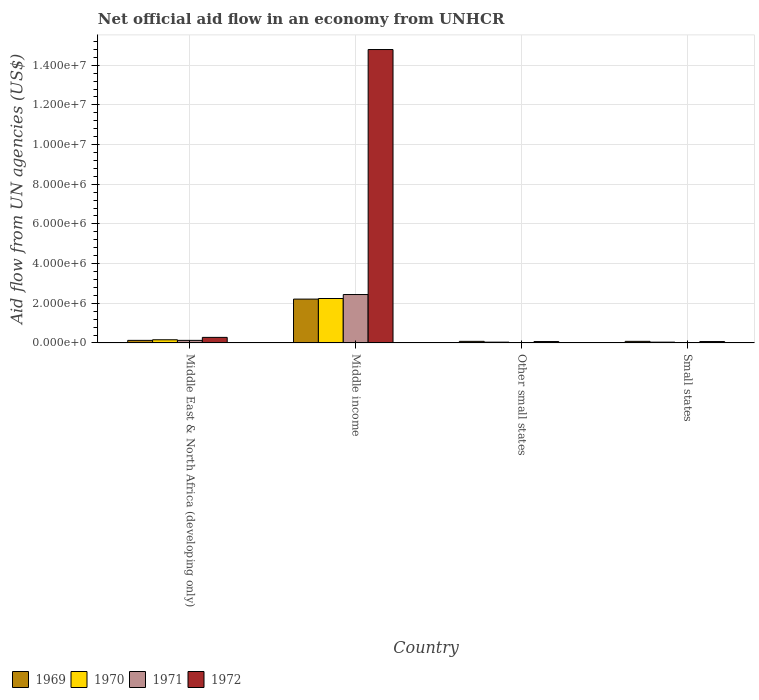How many groups of bars are there?
Provide a short and direct response. 4. Are the number of bars per tick equal to the number of legend labels?
Your answer should be compact. Yes. Are the number of bars on each tick of the X-axis equal?
Your answer should be very brief. Yes. How many bars are there on the 4th tick from the left?
Ensure brevity in your answer.  4. How many bars are there on the 1st tick from the right?
Give a very brief answer. 4. What is the label of the 4th group of bars from the left?
Give a very brief answer. Small states. Across all countries, what is the maximum net official aid flow in 1970?
Provide a succinct answer. 2.24e+06. Across all countries, what is the minimum net official aid flow in 1970?
Provide a succinct answer. 4.00e+04. In which country was the net official aid flow in 1969 minimum?
Your answer should be compact. Other small states. What is the total net official aid flow in 1970 in the graph?
Offer a very short reply. 2.48e+06. What is the difference between the net official aid flow in 1972 in Middle East & North Africa (developing only) and that in Middle income?
Make the answer very short. -1.45e+07. What is the difference between the net official aid flow in 1972 in Middle income and the net official aid flow in 1969 in Other small states?
Your answer should be compact. 1.47e+07. What is the average net official aid flow in 1970 per country?
Provide a succinct answer. 6.20e+05. What is the difference between the net official aid flow of/in 1972 and net official aid flow of/in 1971 in Middle income?
Provide a succinct answer. 1.24e+07. In how many countries, is the net official aid flow in 1969 greater than 14000000 US$?
Offer a terse response. 0. Is the net official aid flow in 1972 in Middle East & North Africa (developing only) less than that in Middle income?
Keep it short and to the point. Yes. What is the difference between the highest and the second highest net official aid flow in 1971?
Your answer should be compact. 2.42e+06. What is the difference between the highest and the lowest net official aid flow in 1971?
Offer a very short reply. 2.42e+06. Is it the case that in every country, the sum of the net official aid flow in 1971 and net official aid flow in 1969 is greater than the sum of net official aid flow in 1972 and net official aid flow in 1970?
Make the answer very short. No. What does the 1st bar from the left in Small states represents?
Provide a short and direct response. 1969. Is it the case that in every country, the sum of the net official aid flow in 1971 and net official aid flow in 1972 is greater than the net official aid flow in 1970?
Your answer should be very brief. Yes. What is the difference between two consecutive major ticks on the Y-axis?
Keep it short and to the point. 2.00e+06. Are the values on the major ticks of Y-axis written in scientific E-notation?
Your answer should be compact. Yes. Where does the legend appear in the graph?
Your answer should be compact. Bottom left. How are the legend labels stacked?
Offer a terse response. Horizontal. What is the title of the graph?
Offer a terse response. Net official aid flow in an economy from UNHCR. What is the label or title of the Y-axis?
Provide a short and direct response. Aid flow from UN agencies (US$). What is the Aid flow from UN agencies (US$) of 1969 in Middle East & North Africa (developing only)?
Provide a succinct answer. 1.30e+05. What is the Aid flow from UN agencies (US$) of 1970 in Middle East & North Africa (developing only)?
Give a very brief answer. 1.60e+05. What is the Aid flow from UN agencies (US$) in 1971 in Middle East & North Africa (developing only)?
Provide a short and direct response. 1.30e+05. What is the Aid flow from UN agencies (US$) in 1972 in Middle East & North Africa (developing only)?
Your response must be concise. 2.80e+05. What is the Aid flow from UN agencies (US$) in 1969 in Middle income?
Offer a terse response. 2.21e+06. What is the Aid flow from UN agencies (US$) in 1970 in Middle income?
Your answer should be very brief. 2.24e+06. What is the Aid flow from UN agencies (US$) of 1971 in Middle income?
Your answer should be compact. 2.44e+06. What is the Aid flow from UN agencies (US$) in 1972 in Middle income?
Make the answer very short. 1.48e+07. What is the Aid flow from UN agencies (US$) of 1970 in Other small states?
Your response must be concise. 4.00e+04. What is the Aid flow from UN agencies (US$) of 1971 in Other small states?
Provide a short and direct response. 2.00e+04. What is the Aid flow from UN agencies (US$) of 1972 in Other small states?
Make the answer very short. 7.00e+04. What is the Aid flow from UN agencies (US$) of 1970 in Small states?
Your response must be concise. 4.00e+04. What is the Aid flow from UN agencies (US$) of 1972 in Small states?
Provide a short and direct response. 7.00e+04. Across all countries, what is the maximum Aid flow from UN agencies (US$) in 1969?
Ensure brevity in your answer.  2.21e+06. Across all countries, what is the maximum Aid flow from UN agencies (US$) in 1970?
Ensure brevity in your answer.  2.24e+06. Across all countries, what is the maximum Aid flow from UN agencies (US$) in 1971?
Give a very brief answer. 2.44e+06. Across all countries, what is the maximum Aid flow from UN agencies (US$) of 1972?
Keep it short and to the point. 1.48e+07. Across all countries, what is the minimum Aid flow from UN agencies (US$) in 1969?
Offer a terse response. 8.00e+04. Across all countries, what is the minimum Aid flow from UN agencies (US$) of 1970?
Provide a short and direct response. 4.00e+04. Across all countries, what is the minimum Aid flow from UN agencies (US$) in 1971?
Keep it short and to the point. 2.00e+04. What is the total Aid flow from UN agencies (US$) of 1969 in the graph?
Offer a very short reply. 2.50e+06. What is the total Aid flow from UN agencies (US$) in 1970 in the graph?
Your response must be concise. 2.48e+06. What is the total Aid flow from UN agencies (US$) in 1971 in the graph?
Your response must be concise. 2.61e+06. What is the total Aid flow from UN agencies (US$) in 1972 in the graph?
Keep it short and to the point. 1.52e+07. What is the difference between the Aid flow from UN agencies (US$) in 1969 in Middle East & North Africa (developing only) and that in Middle income?
Provide a short and direct response. -2.08e+06. What is the difference between the Aid flow from UN agencies (US$) of 1970 in Middle East & North Africa (developing only) and that in Middle income?
Provide a short and direct response. -2.08e+06. What is the difference between the Aid flow from UN agencies (US$) of 1971 in Middle East & North Africa (developing only) and that in Middle income?
Your answer should be compact. -2.31e+06. What is the difference between the Aid flow from UN agencies (US$) in 1972 in Middle East & North Africa (developing only) and that in Middle income?
Provide a succinct answer. -1.45e+07. What is the difference between the Aid flow from UN agencies (US$) in 1969 in Middle East & North Africa (developing only) and that in Other small states?
Your answer should be very brief. 5.00e+04. What is the difference between the Aid flow from UN agencies (US$) of 1970 in Middle East & North Africa (developing only) and that in Other small states?
Your answer should be compact. 1.20e+05. What is the difference between the Aid flow from UN agencies (US$) of 1972 in Middle East & North Africa (developing only) and that in Other small states?
Make the answer very short. 2.10e+05. What is the difference between the Aid flow from UN agencies (US$) of 1969 in Middle East & North Africa (developing only) and that in Small states?
Your answer should be compact. 5.00e+04. What is the difference between the Aid flow from UN agencies (US$) in 1969 in Middle income and that in Other small states?
Give a very brief answer. 2.13e+06. What is the difference between the Aid flow from UN agencies (US$) of 1970 in Middle income and that in Other small states?
Ensure brevity in your answer.  2.20e+06. What is the difference between the Aid flow from UN agencies (US$) of 1971 in Middle income and that in Other small states?
Give a very brief answer. 2.42e+06. What is the difference between the Aid flow from UN agencies (US$) in 1972 in Middle income and that in Other small states?
Your answer should be compact. 1.47e+07. What is the difference between the Aid flow from UN agencies (US$) of 1969 in Middle income and that in Small states?
Make the answer very short. 2.13e+06. What is the difference between the Aid flow from UN agencies (US$) of 1970 in Middle income and that in Small states?
Keep it short and to the point. 2.20e+06. What is the difference between the Aid flow from UN agencies (US$) of 1971 in Middle income and that in Small states?
Offer a very short reply. 2.42e+06. What is the difference between the Aid flow from UN agencies (US$) of 1972 in Middle income and that in Small states?
Provide a succinct answer. 1.47e+07. What is the difference between the Aid flow from UN agencies (US$) in 1970 in Other small states and that in Small states?
Ensure brevity in your answer.  0. What is the difference between the Aid flow from UN agencies (US$) in 1971 in Other small states and that in Small states?
Ensure brevity in your answer.  0. What is the difference between the Aid flow from UN agencies (US$) of 1969 in Middle East & North Africa (developing only) and the Aid flow from UN agencies (US$) of 1970 in Middle income?
Offer a terse response. -2.11e+06. What is the difference between the Aid flow from UN agencies (US$) in 1969 in Middle East & North Africa (developing only) and the Aid flow from UN agencies (US$) in 1971 in Middle income?
Your answer should be compact. -2.31e+06. What is the difference between the Aid flow from UN agencies (US$) in 1969 in Middle East & North Africa (developing only) and the Aid flow from UN agencies (US$) in 1972 in Middle income?
Your answer should be compact. -1.47e+07. What is the difference between the Aid flow from UN agencies (US$) in 1970 in Middle East & North Africa (developing only) and the Aid flow from UN agencies (US$) in 1971 in Middle income?
Give a very brief answer. -2.28e+06. What is the difference between the Aid flow from UN agencies (US$) of 1970 in Middle East & North Africa (developing only) and the Aid flow from UN agencies (US$) of 1972 in Middle income?
Keep it short and to the point. -1.46e+07. What is the difference between the Aid flow from UN agencies (US$) in 1971 in Middle East & North Africa (developing only) and the Aid flow from UN agencies (US$) in 1972 in Middle income?
Make the answer very short. -1.47e+07. What is the difference between the Aid flow from UN agencies (US$) of 1969 in Middle East & North Africa (developing only) and the Aid flow from UN agencies (US$) of 1971 in Other small states?
Offer a very short reply. 1.10e+05. What is the difference between the Aid flow from UN agencies (US$) of 1970 in Middle East & North Africa (developing only) and the Aid flow from UN agencies (US$) of 1971 in Other small states?
Keep it short and to the point. 1.40e+05. What is the difference between the Aid flow from UN agencies (US$) of 1970 in Middle East & North Africa (developing only) and the Aid flow from UN agencies (US$) of 1972 in Other small states?
Ensure brevity in your answer.  9.00e+04. What is the difference between the Aid flow from UN agencies (US$) in 1971 in Middle East & North Africa (developing only) and the Aid flow from UN agencies (US$) in 1972 in Other small states?
Your response must be concise. 6.00e+04. What is the difference between the Aid flow from UN agencies (US$) of 1969 in Middle East & North Africa (developing only) and the Aid flow from UN agencies (US$) of 1970 in Small states?
Ensure brevity in your answer.  9.00e+04. What is the difference between the Aid flow from UN agencies (US$) of 1969 in Middle East & North Africa (developing only) and the Aid flow from UN agencies (US$) of 1972 in Small states?
Your answer should be compact. 6.00e+04. What is the difference between the Aid flow from UN agencies (US$) in 1970 in Middle East & North Africa (developing only) and the Aid flow from UN agencies (US$) in 1971 in Small states?
Offer a terse response. 1.40e+05. What is the difference between the Aid flow from UN agencies (US$) of 1970 in Middle East & North Africa (developing only) and the Aid flow from UN agencies (US$) of 1972 in Small states?
Make the answer very short. 9.00e+04. What is the difference between the Aid flow from UN agencies (US$) in 1971 in Middle East & North Africa (developing only) and the Aid flow from UN agencies (US$) in 1972 in Small states?
Provide a succinct answer. 6.00e+04. What is the difference between the Aid flow from UN agencies (US$) in 1969 in Middle income and the Aid flow from UN agencies (US$) in 1970 in Other small states?
Ensure brevity in your answer.  2.17e+06. What is the difference between the Aid flow from UN agencies (US$) in 1969 in Middle income and the Aid flow from UN agencies (US$) in 1971 in Other small states?
Provide a short and direct response. 2.19e+06. What is the difference between the Aid flow from UN agencies (US$) of 1969 in Middle income and the Aid flow from UN agencies (US$) of 1972 in Other small states?
Offer a very short reply. 2.14e+06. What is the difference between the Aid flow from UN agencies (US$) of 1970 in Middle income and the Aid flow from UN agencies (US$) of 1971 in Other small states?
Make the answer very short. 2.22e+06. What is the difference between the Aid flow from UN agencies (US$) in 1970 in Middle income and the Aid flow from UN agencies (US$) in 1972 in Other small states?
Ensure brevity in your answer.  2.17e+06. What is the difference between the Aid flow from UN agencies (US$) of 1971 in Middle income and the Aid flow from UN agencies (US$) of 1972 in Other small states?
Keep it short and to the point. 2.37e+06. What is the difference between the Aid flow from UN agencies (US$) of 1969 in Middle income and the Aid flow from UN agencies (US$) of 1970 in Small states?
Offer a very short reply. 2.17e+06. What is the difference between the Aid flow from UN agencies (US$) of 1969 in Middle income and the Aid flow from UN agencies (US$) of 1971 in Small states?
Your answer should be very brief. 2.19e+06. What is the difference between the Aid flow from UN agencies (US$) of 1969 in Middle income and the Aid flow from UN agencies (US$) of 1972 in Small states?
Your answer should be compact. 2.14e+06. What is the difference between the Aid flow from UN agencies (US$) of 1970 in Middle income and the Aid flow from UN agencies (US$) of 1971 in Small states?
Your answer should be compact. 2.22e+06. What is the difference between the Aid flow from UN agencies (US$) of 1970 in Middle income and the Aid flow from UN agencies (US$) of 1972 in Small states?
Offer a very short reply. 2.17e+06. What is the difference between the Aid flow from UN agencies (US$) of 1971 in Middle income and the Aid flow from UN agencies (US$) of 1972 in Small states?
Your answer should be compact. 2.37e+06. What is the difference between the Aid flow from UN agencies (US$) in 1969 in Other small states and the Aid flow from UN agencies (US$) in 1970 in Small states?
Your answer should be compact. 4.00e+04. What is the difference between the Aid flow from UN agencies (US$) in 1969 in Other small states and the Aid flow from UN agencies (US$) in 1971 in Small states?
Your answer should be compact. 6.00e+04. What is the difference between the Aid flow from UN agencies (US$) of 1969 in Other small states and the Aid flow from UN agencies (US$) of 1972 in Small states?
Keep it short and to the point. 10000. What is the difference between the Aid flow from UN agencies (US$) of 1971 in Other small states and the Aid flow from UN agencies (US$) of 1972 in Small states?
Offer a very short reply. -5.00e+04. What is the average Aid flow from UN agencies (US$) of 1969 per country?
Make the answer very short. 6.25e+05. What is the average Aid flow from UN agencies (US$) of 1970 per country?
Ensure brevity in your answer.  6.20e+05. What is the average Aid flow from UN agencies (US$) in 1971 per country?
Provide a short and direct response. 6.52e+05. What is the average Aid flow from UN agencies (US$) of 1972 per country?
Give a very brief answer. 3.80e+06. What is the difference between the Aid flow from UN agencies (US$) in 1969 and Aid flow from UN agencies (US$) in 1971 in Middle East & North Africa (developing only)?
Your answer should be compact. 0. What is the difference between the Aid flow from UN agencies (US$) in 1970 and Aid flow from UN agencies (US$) in 1971 in Middle East & North Africa (developing only)?
Ensure brevity in your answer.  3.00e+04. What is the difference between the Aid flow from UN agencies (US$) in 1970 and Aid flow from UN agencies (US$) in 1972 in Middle East & North Africa (developing only)?
Offer a very short reply. -1.20e+05. What is the difference between the Aid flow from UN agencies (US$) in 1971 and Aid flow from UN agencies (US$) in 1972 in Middle East & North Africa (developing only)?
Provide a succinct answer. -1.50e+05. What is the difference between the Aid flow from UN agencies (US$) in 1969 and Aid flow from UN agencies (US$) in 1970 in Middle income?
Your answer should be very brief. -3.00e+04. What is the difference between the Aid flow from UN agencies (US$) of 1969 and Aid flow from UN agencies (US$) of 1971 in Middle income?
Ensure brevity in your answer.  -2.30e+05. What is the difference between the Aid flow from UN agencies (US$) in 1969 and Aid flow from UN agencies (US$) in 1972 in Middle income?
Ensure brevity in your answer.  -1.26e+07. What is the difference between the Aid flow from UN agencies (US$) of 1970 and Aid flow from UN agencies (US$) of 1971 in Middle income?
Keep it short and to the point. -2.00e+05. What is the difference between the Aid flow from UN agencies (US$) of 1970 and Aid flow from UN agencies (US$) of 1972 in Middle income?
Your answer should be compact. -1.26e+07. What is the difference between the Aid flow from UN agencies (US$) of 1971 and Aid flow from UN agencies (US$) of 1972 in Middle income?
Your response must be concise. -1.24e+07. What is the difference between the Aid flow from UN agencies (US$) in 1969 and Aid flow from UN agencies (US$) in 1971 in Other small states?
Ensure brevity in your answer.  6.00e+04. What is the difference between the Aid flow from UN agencies (US$) in 1969 and Aid flow from UN agencies (US$) in 1971 in Small states?
Make the answer very short. 6.00e+04. What is the difference between the Aid flow from UN agencies (US$) of 1970 and Aid flow from UN agencies (US$) of 1971 in Small states?
Make the answer very short. 2.00e+04. What is the difference between the Aid flow from UN agencies (US$) in 1971 and Aid flow from UN agencies (US$) in 1972 in Small states?
Provide a succinct answer. -5.00e+04. What is the ratio of the Aid flow from UN agencies (US$) in 1969 in Middle East & North Africa (developing only) to that in Middle income?
Your answer should be very brief. 0.06. What is the ratio of the Aid flow from UN agencies (US$) in 1970 in Middle East & North Africa (developing only) to that in Middle income?
Provide a short and direct response. 0.07. What is the ratio of the Aid flow from UN agencies (US$) of 1971 in Middle East & North Africa (developing only) to that in Middle income?
Offer a very short reply. 0.05. What is the ratio of the Aid flow from UN agencies (US$) of 1972 in Middle East & North Africa (developing only) to that in Middle income?
Your answer should be very brief. 0.02. What is the ratio of the Aid flow from UN agencies (US$) in 1969 in Middle East & North Africa (developing only) to that in Other small states?
Offer a very short reply. 1.62. What is the ratio of the Aid flow from UN agencies (US$) in 1972 in Middle East & North Africa (developing only) to that in Other small states?
Your answer should be very brief. 4. What is the ratio of the Aid flow from UN agencies (US$) of 1969 in Middle East & North Africa (developing only) to that in Small states?
Provide a succinct answer. 1.62. What is the ratio of the Aid flow from UN agencies (US$) of 1970 in Middle East & North Africa (developing only) to that in Small states?
Offer a very short reply. 4. What is the ratio of the Aid flow from UN agencies (US$) in 1972 in Middle East & North Africa (developing only) to that in Small states?
Provide a succinct answer. 4. What is the ratio of the Aid flow from UN agencies (US$) of 1969 in Middle income to that in Other small states?
Keep it short and to the point. 27.62. What is the ratio of the Aid flow from UN agencies (US$) of 1971 in Middle income to that in Other small states?
Your answer should be compact. 122. What is the ratio of the Aid flow from UN agencies (US$) in 1972 in Middle income to that in Other small states?
Provide a short and direct response. 211.29. What is the ratio of the Aid flow from UN agencies (US$) in 1969 in Middle income to that in Small states?
Provide a succinct answer. 27.62. What is the ratio of the Aid flow from UN agencies (US$) in 1970 in Middle income to that in Small states?
Offer a very short reply. 56. What is the ratio of the Aid flow from UN agencies (US$) of 1971 in Middle income to that in Small states?
Offer a terse response. 122. What is the ratio of the Aid flow from UN agencies (US$) of 1972 in Middle income to that in Small states?
Keep it short and to the point. 211.29. What is the difference between the highest and the second highest Aid flow from UN agencies (US$) of 1969?
Offer a terse response. 2.08e+06. What is the difference between the highest and the second highest Aid flow from UN agencies (US$) of 1970?
Your answer should be very brief. 2.08e+06. What is the difference between the highest and the second highest Aid flow from UN agencies (US$) of 1971?
Your response must be concise. 2.31e+06. What is the difference between the highest and the second highest Aid flow from UN agencies (US$) in 1972?
Your answer should be very brief. 1.45e+07. What is the difference between the highest and the lowest Aid flow from UN agencies (US$) of 1969?
Make the answer very short. 2.13e+06. What is the difference between the highest and the lowest Aid flow from UN agencies (US$) of 1970?
Provide a short and direct response. 2.20e+06. What is the difference between the highest and the lowest Aid flow from UN agencies (US$) in 1971?
Provide a short and direct response. 2.42e+06. What is the difference between the highest and the lowest Aid flow from UN agencies (US$) of 1972?
Your answer should be very brief. 1.47e+07. 